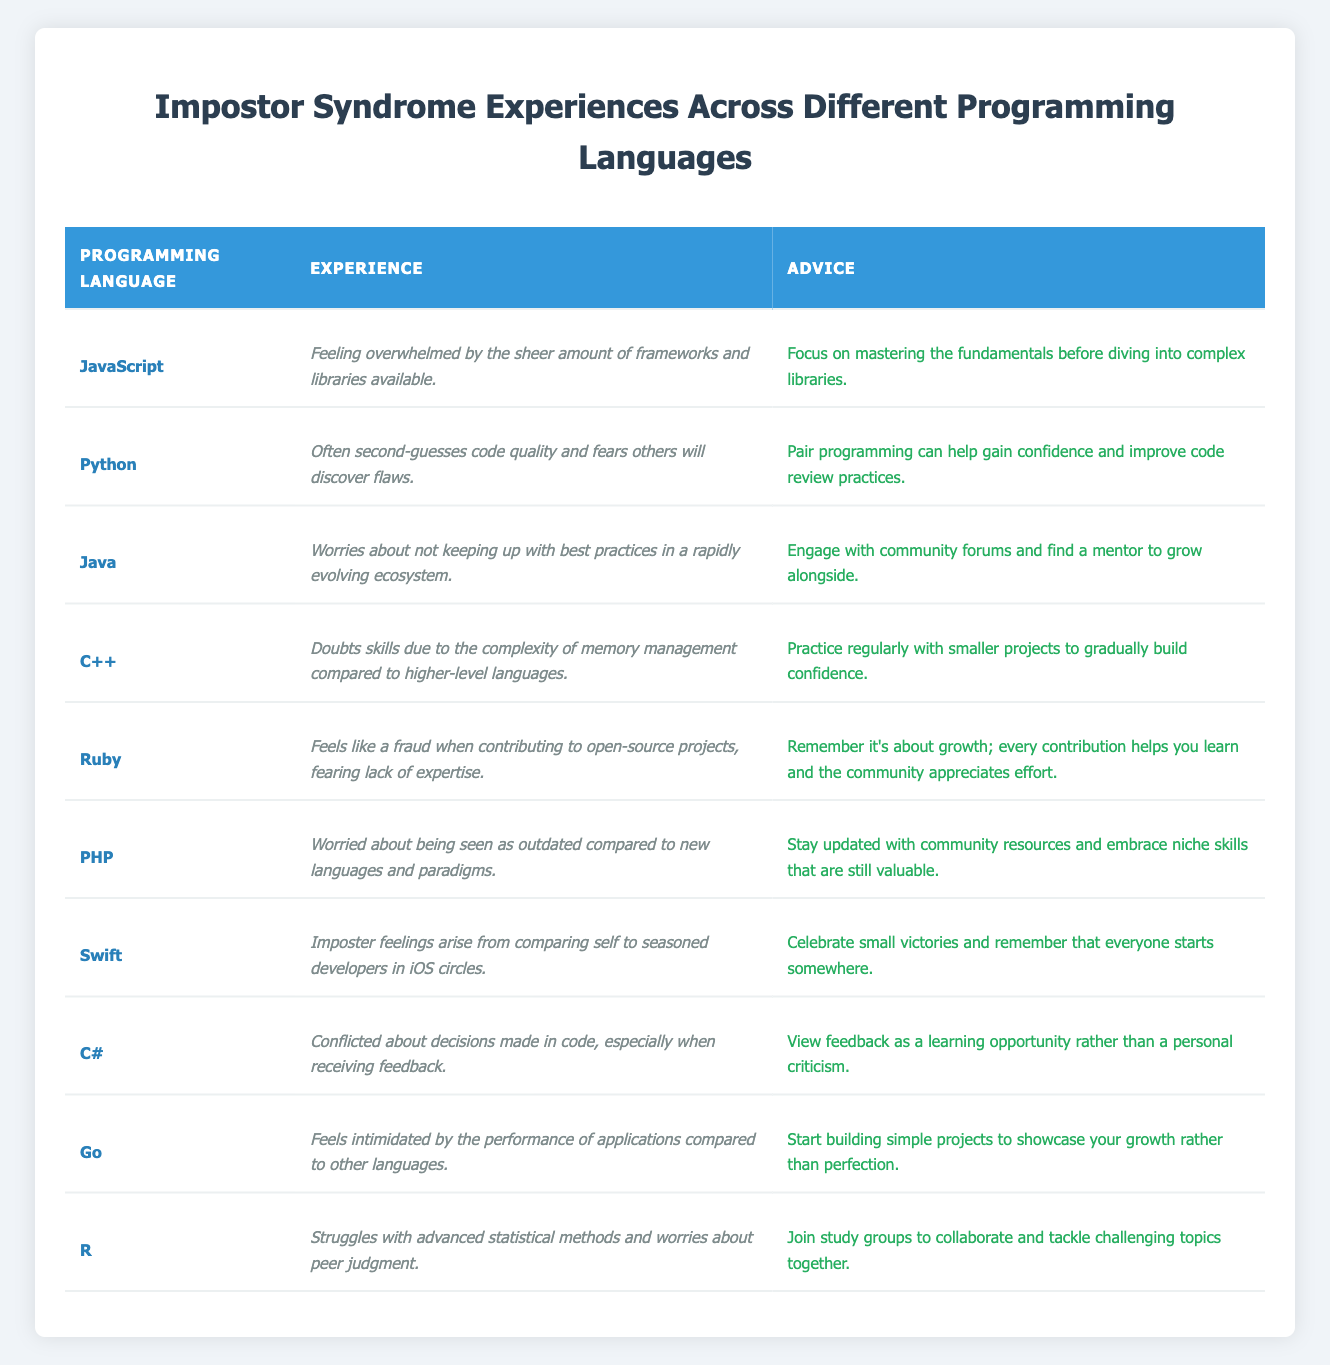What programming language's experience mentions feeling overwhelmed by frameworks and libraries? The table shows that JavaScript is associated with the experience of feeling overwhelmed by the sheer amount of frameworks and libraries available.
Answer: JavaScript Which programming language has advice related to fearing others will discover flaws? The experience listed for Python states that individuals often second-guess code quality and fear others will discover flaws. This corresponds to advice on improving code review practices.
Answer: Python Does Ruby mention a feeling of fraud when contributing to projects? The table indicates that Ruby's experience includes feeling like a fraud when contributing to open-source projects, fearing lack of expertise. Thus, it confirms the fact.
Answer: Yes What experience is associated with Go? According to the table, the experience associated with Go is feeling intimidated by the performance of applications compared to other languages.
Answer: Intimidated by performance Which programming language has the most positive advice regarding perceived problems? The advice related to Ruby emphasizes growth with every contribution to open-source initiatives, highlighting the community's appreciation. This shows a positive outlook compared to others.
Answer: Ruby What is the common advice given to deal with feelings of imposter syndrome among the programming languages listed? There is a recurring theme in the advice across various languages emphasizing the importance of community support, seeking mentorship, or gaining experience through practice. This collectively points to a supportive approach.
Answer: Community support and mentorship How many programming languages mention struggling with self-comparison? The table indicates two programming languages—Swift regarding comparisons to seasoned developers and Python with second-guessing—suggesting struggling with self-comparison. It sums to two overall.
Answer: Two Which programming language identifies worries about not keeping up with best practices? The experience detailed for Java expresses worries about not keeping up with best practices in a rapidly evolving ecosystem.
Answer: Java Calculate how many programming languages have advice focused on community engagement or collaboration. From the table, the advice for Python mentions pair programming, Java encourages community forum engagement, Ruby suggests contributions help learning, C# advises viewing feedback positively, and R proposes joining study groups. This results in five languages.
Answer: Five Is there an experience related to memory management mentioned for C++? The experience listed for C++ specifically doubts skills due to the complexity of memory management, confirming its mention.
Answer: Yes What advice is given for handling imposter feelings in Swift? The table states that in the case of Swift, the advice is to celebrate small victories and remember that everyone starts somewhere, helping to counter feelings of inadequacy.
Answer: Celebrate small victories 